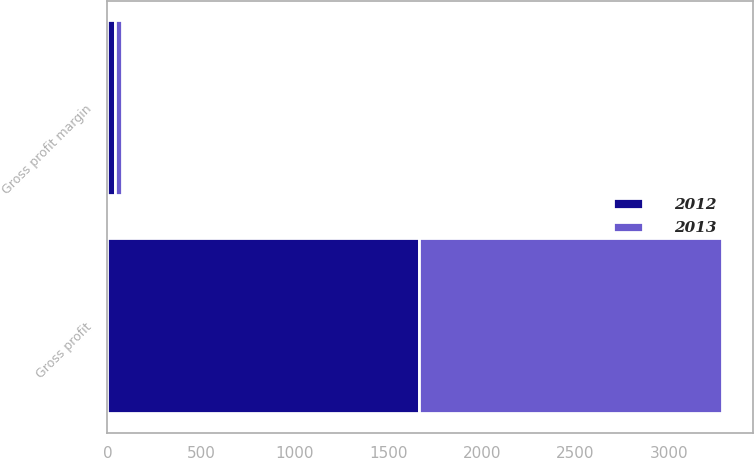Convert chart. <chart><loc_0><loc_0><loc_500><loc_500><stacked_bar_chart><ecel><fcel>Gross profit<fcel>Gross profit margin<nl><fcel>2012<fcel>1665.8<fcel>40.4<nl><fcel>2013<fcel>1617.8<fcel>40.3<nl></chart> 